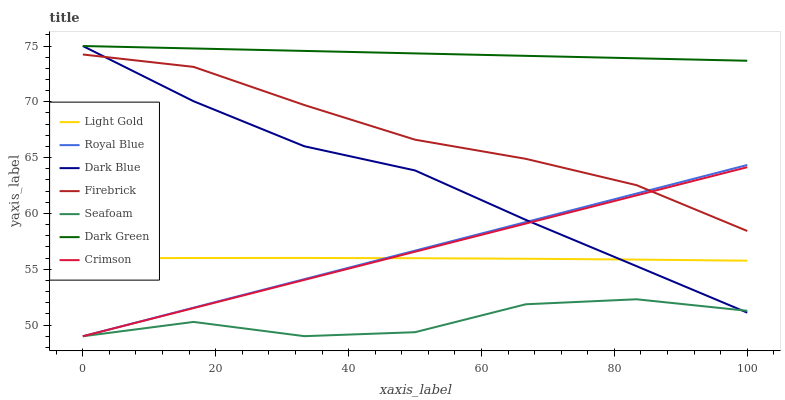Does Seafoam have the minimum area under the curve?
Answer yes or no. Yes. Does Dark Green have the maximum area under the curve?
Answer yes or no. Yes. Does Firebrick have the minimum area under the curve?
Answer yes or no. No. Does Firebrick have the maximum area under the curve?
Answer yes or no. No. Is Royal Blue the smoothest?
Answer yes or no. Yes. Is Seafoam the roughest?
Answer yes or no. Yes. Is Firebrick the smoothest?
Answer yes or no. No. Is Firebrick the roughest?
Answer yes or no. No. Does Seafoam have the lowest value?
Answer yes or no. Yes. Does Firebrick have the lowest value?
Answer yes or no. No. Does Dark Green have the highest value?
Answer yes or no. Yes. Does Firebrick have the highest value?
Answer yes or no. No. Is Royal Blue less than Dark Green?
Answer yes or no. Yes. Is Dark Green greater than Royal Blue?
Answer yes or no. Yes. Does Royal Blue intersect Crimson?
Answer yes or no. Yes. Is Royal Blue less than Crimson?
Answer yes or no. No. Is Royal Blue greater than Crimson?
Answer yes or no. No. Does Royal Blue intersect Dark Green?
Answer yes or no. No. 